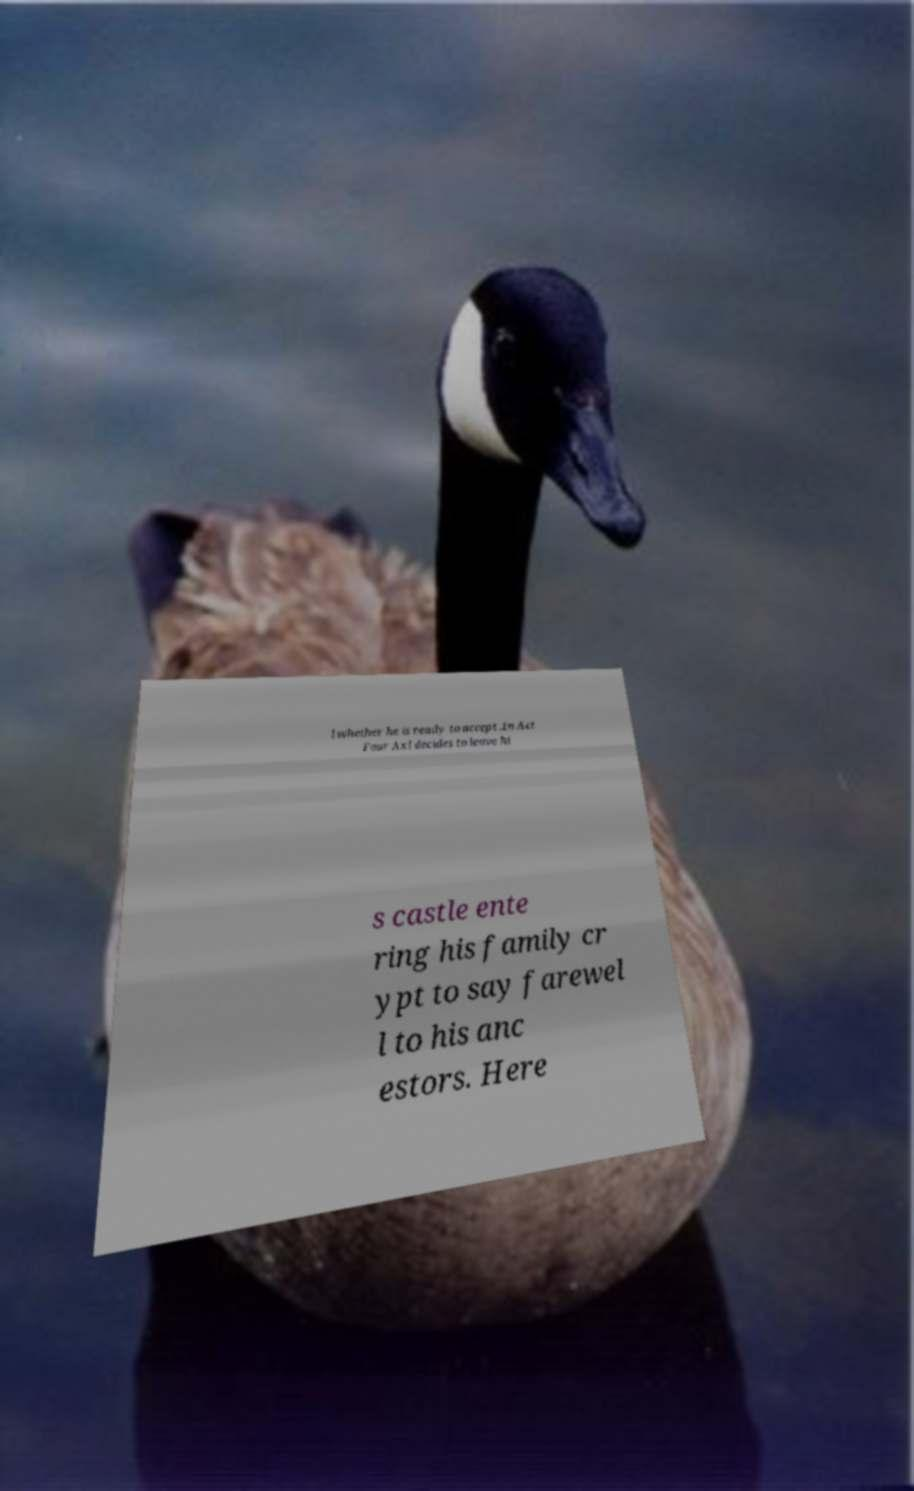Could you assist in decoding the text presented in this image and type it out clearly? l whether he is ready to accept .In Act Four Axl decides to leave hi s castle ente ring his family cr ypt to say farewel l to his anc estors. Here 